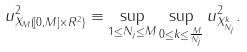<formula> <loc_0><loc_0><loc_500><loc_500>\| u \| _ { X _ { M } ( [ 0 , M ] \times R ^ { 2 } ) } ^ { 2 } \equiv \sup _ { 1 \leq N _ { j } \leq M } \sup _ { 0 \leq k \leq \frac { M } { N _ { j } } } \| u \| _ { X _ { N _ { j } } ^ { k } } ^ { 2 } .</formula> 